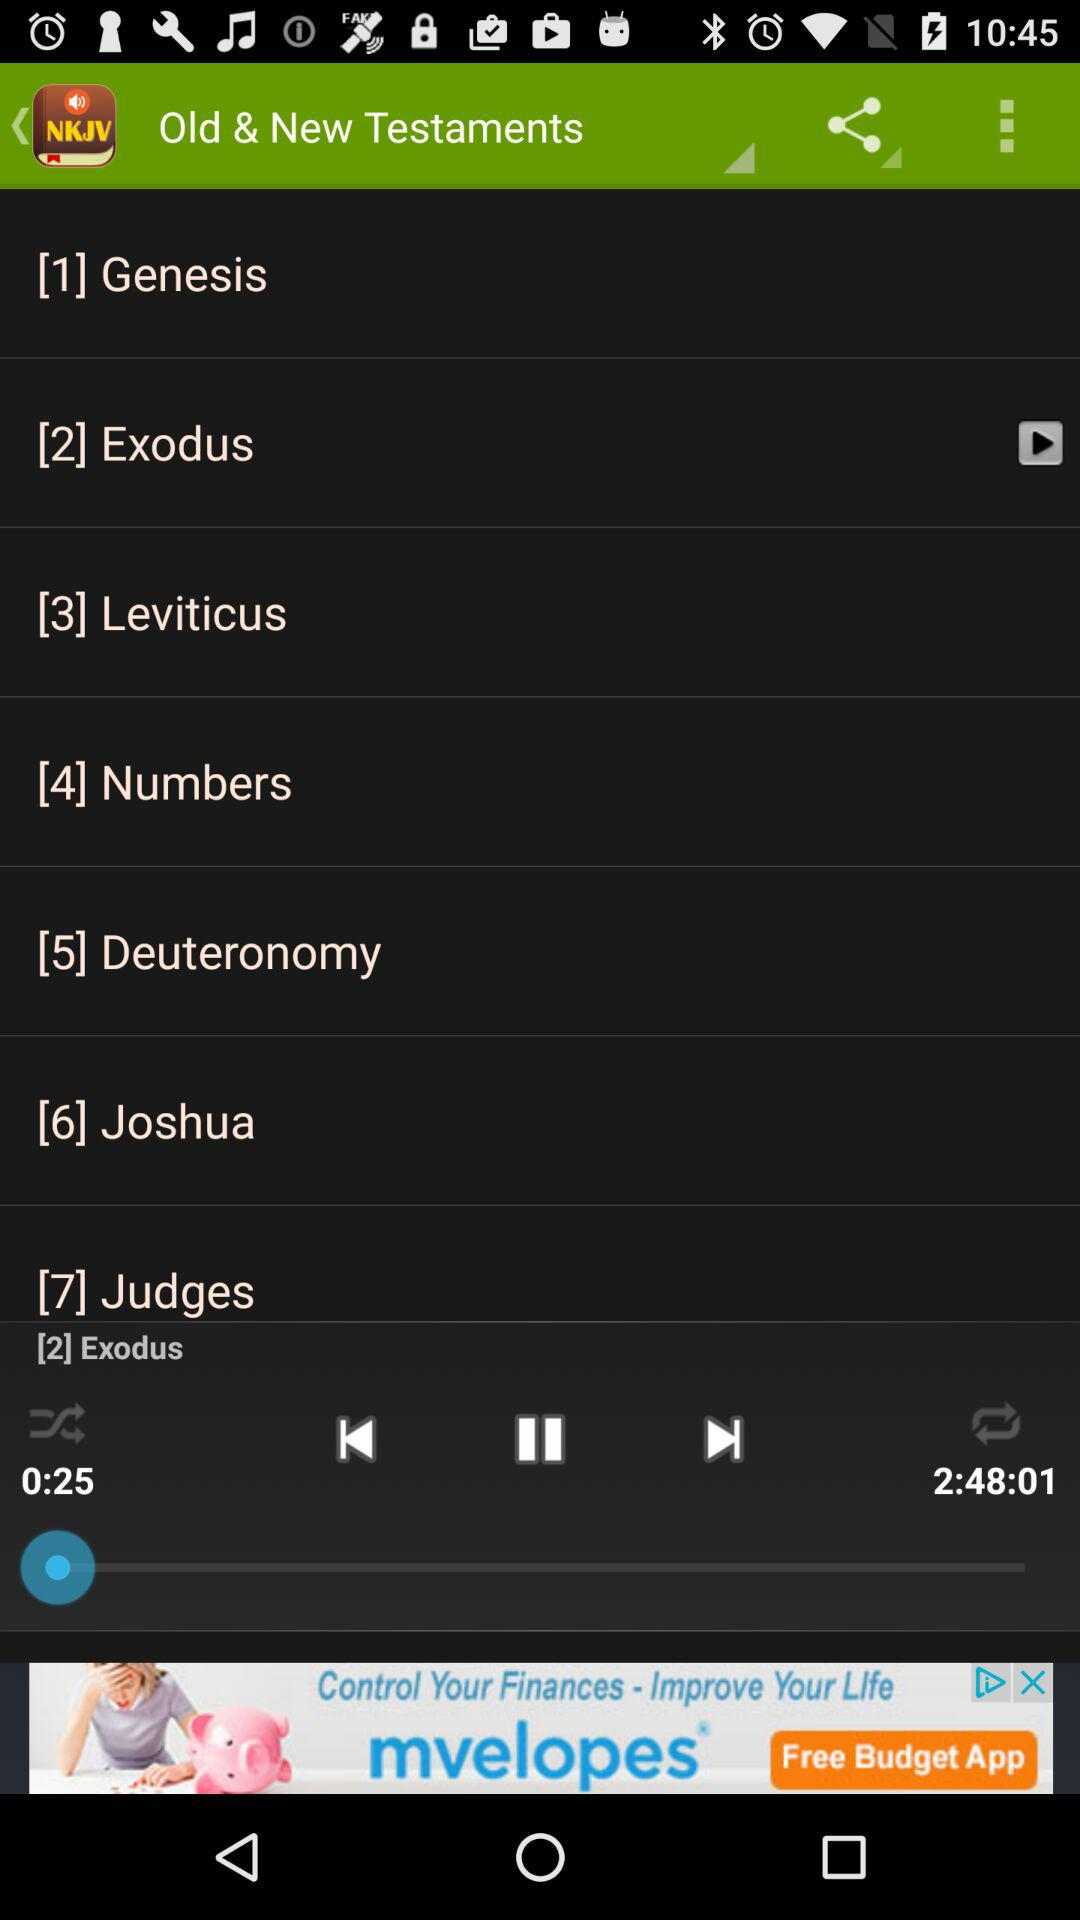What is the name of the audio that is playing? The name of the audio is "Exodus". 